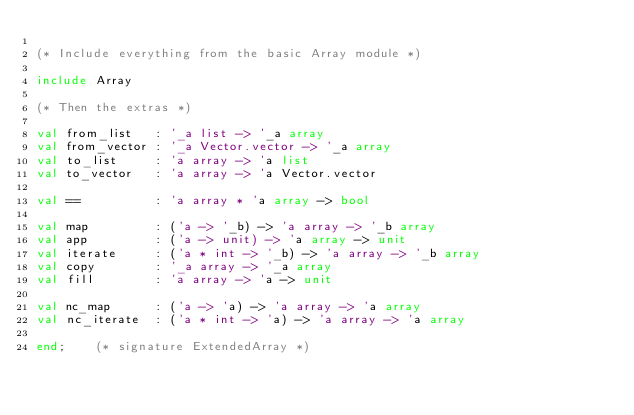Convert code to text. <code><loc_0><loc_0><loc_500><loc_500><_SML_>
(* Include everything from the basic Array module *)

include Array

(* Then the extras *)

val from_list   : '_a list -> '_a array
val from_vector : '_a Vector.vector -> '_a array
val to_list     : 'a array -> 'a list
val to_vector   : 'a array -> 'a Vector.vector

val ==          : 'a array * 'a array -> bool

val map         : ('a -> '_b) -> 'a array -> '_b array
val app         : ('a -> unit) -> 'a array -> unit
val iterate     : ('a * int -> '_b) -> 'a array -> '_b array
val copy        : '_a array -> '_a array
val fill        : 'a array -> 'a -> unit

val nc_map      : ('a -> 'a) -> 'a array -> 'a array
val nc_iterate  : ('a * int -> 'a) -> 'a array -> 'a array

end;    (* signature ExtendedArray *)
</code> 